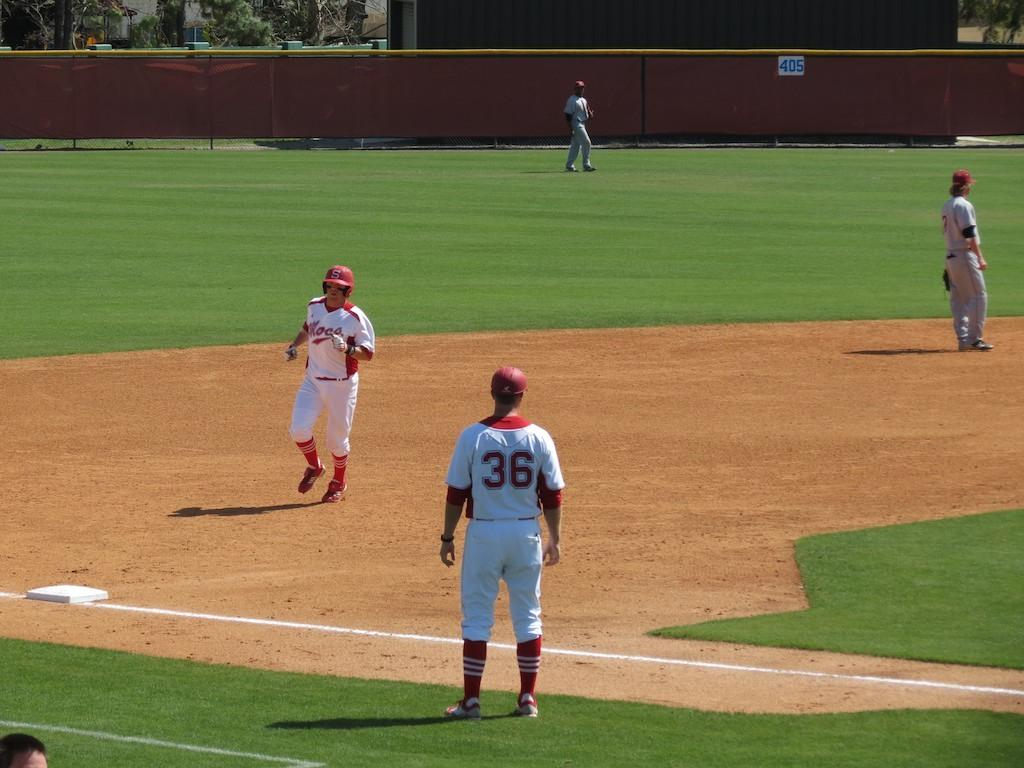<image>
Render a clear and concise summary of the photo. Guys on a baseball field playing ball one has a number 36 on his back. 